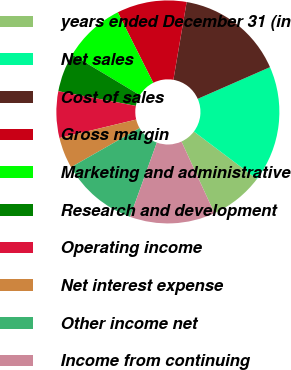Convert chart to OTSL. <chart><loc_0><loc_0><loc_500><loc_500><pie_chart><fcel>years ended December 31 (in<fcel>Net sales<fcel>Cost of sales<fcel>Gross margin<fcel>Marketing and administrative<fcel>Research and development<fcel>Operating income<fcel>Net interest expense<fcel>Other income net<fcel>Income from continuing<nl><fcel>7.87%<fcel>16.85%<fcel>15.73%<fcel>10.11%<fcel>8.99%<fcel>5.62%<fcel>6.74%<fcel>4.49%<fcel>11.24%<fcel>12.36%<nl></chart> 